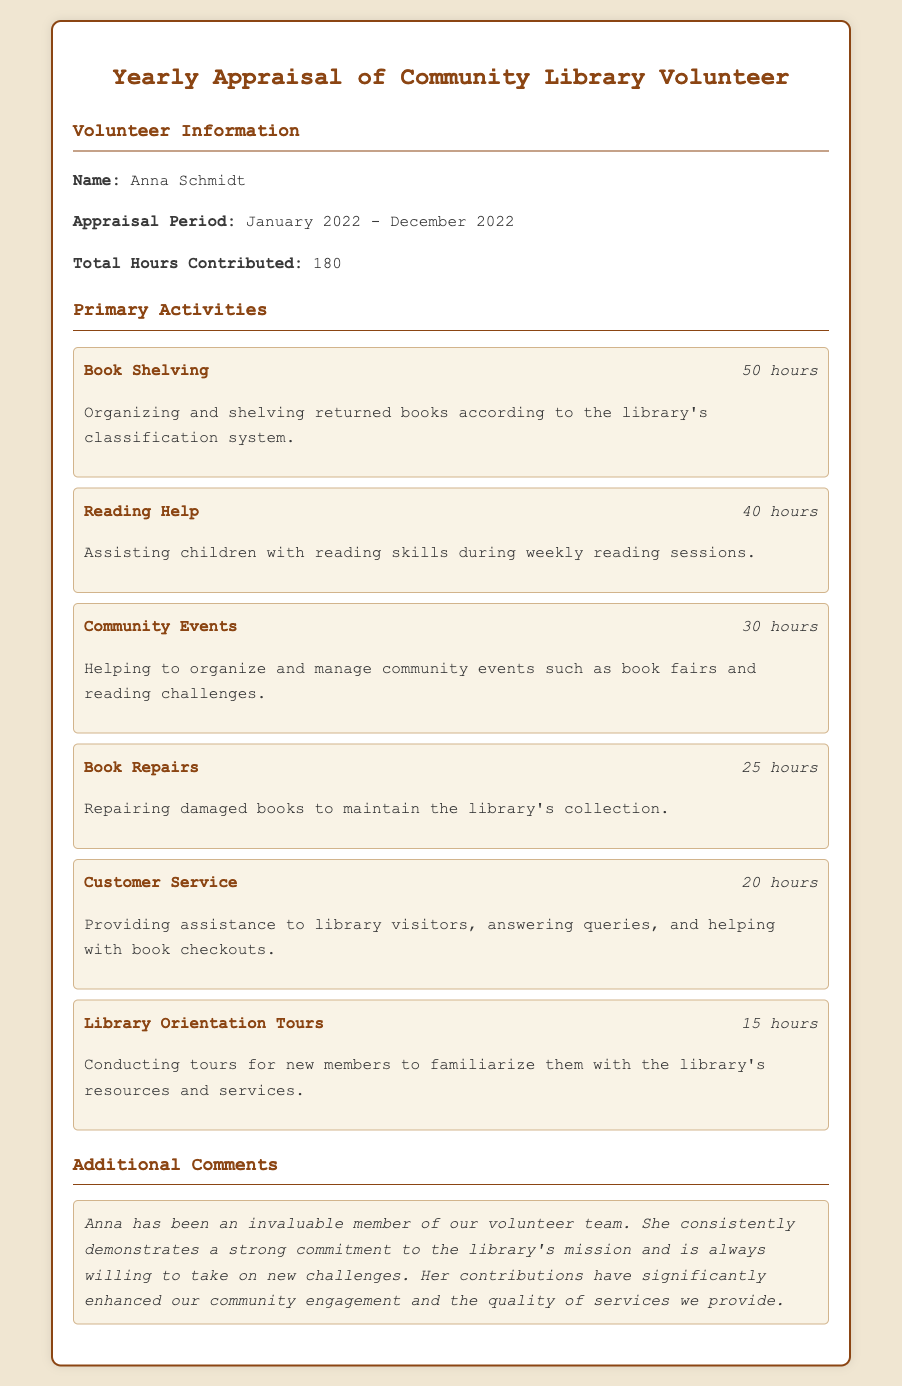What is the name of the volunteer? The volunteer's name is provided in the document under Volunteer Information.
Answer: Anna Schmidt What is the total number of hours contributed? The total hours contributed are mentioned in the Volunteer Information section as a specific figure.
Answer: 180 During which period did the appraisal take place? The appraisal period is stated in the Volunteer Information section.
Answer: January 2022 - December 2022 How many hours were spent on Book Shelving? The hours for Book Shelving are listed in the Primary Activities section next to the activity name.
Answer: 50 hours What activity took the least amount of time? The activity with the least hours is identified in the Primary Activities section.
Answer: Library Orientation Tours How many hours were dedicated to Community Events? The document states the number of hours for Community Events in the activity list.
Answer: 30 hours What is noted in the Additional Comments section? The Additional Comments section includes a summary of the volunteer's contributions and impact.
Answer: Anna has been an invaluable member of our volunteer team What type of repairs did Anna contribute to? The type of repairs performed by Anna is specified in the Primary Activities section.
Answer: Book Repairs What indicates the main purpose of the Volunteer roles? The description of primary activities illustrates the main responsibilities and purposes for the volunteer roles.
Answer: Enhancing community engagement 